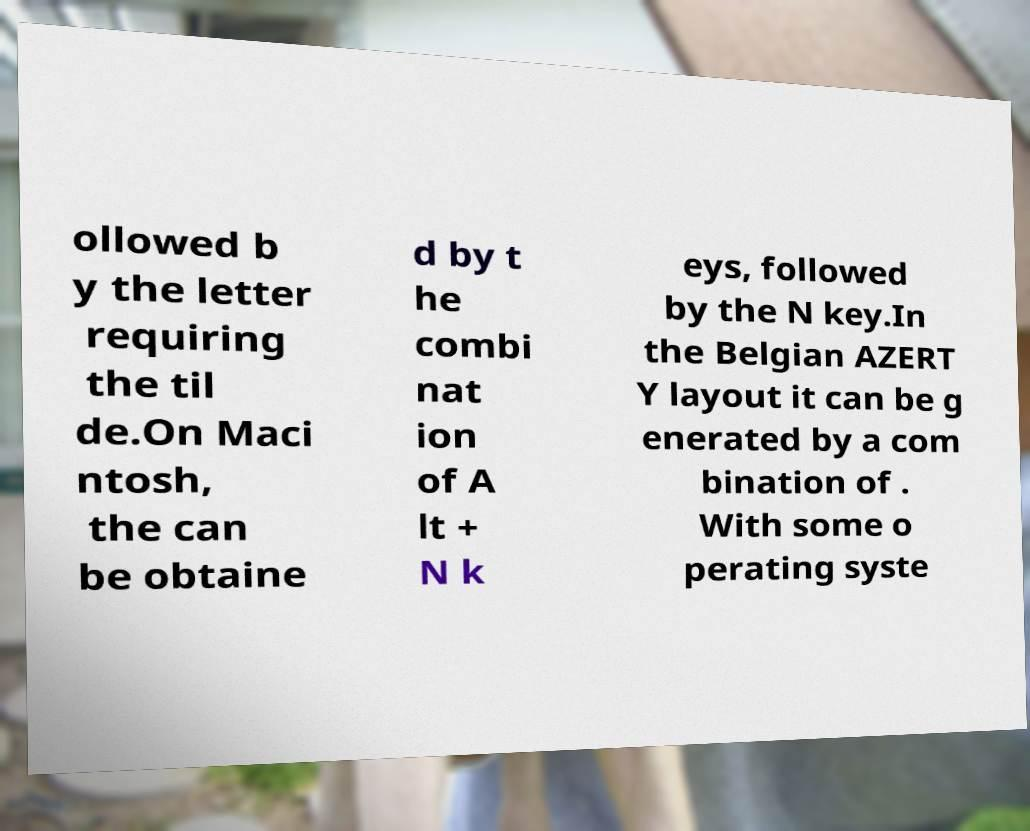I need the written content from this picture converted into text. Can you do that? ollowed b y the letter requiring the til de.On Maci ntosh, the can be obtaine d by t he combi nat ion of A lt + N k eys, followed by the N key.In the Belgian AZERT Y layout it can be g enerated by a com bination of . With some o perating syste 